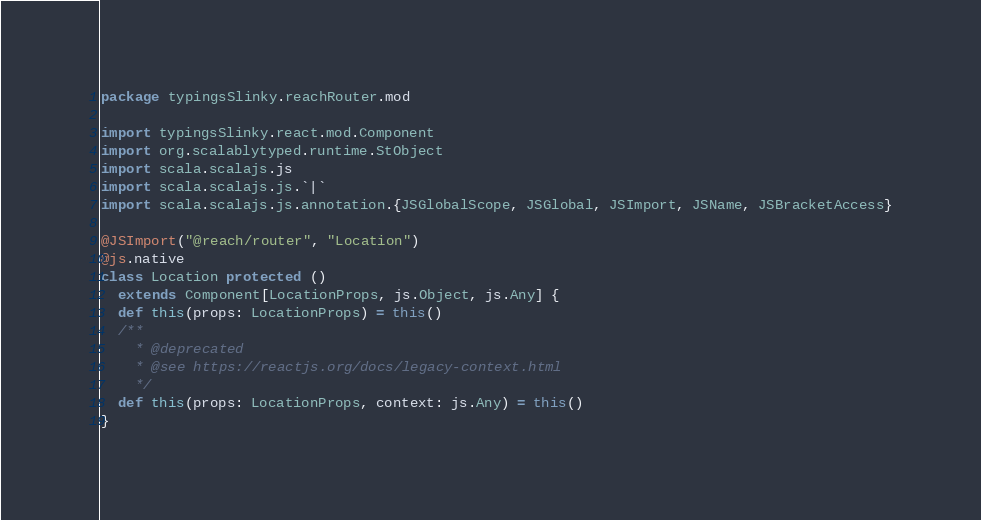Convert code to text. <code><loc_0><loc_0><loc_500><loc_500><_Scala_>package typingsSlinky.reachRouter.mod

import typingsSlinky.react.mod.Component
import org.scalablytyped.runtime.StObject
import scala.scalajs.js
import scala.scalajs.js.`|`
import scala.scalajs.js.annotation.{JSGlobalScope, JSGlobal, JSImport, JSName, JSBracketAccess}

@JSImport("@reach/router", "Location")
@js.native
class Location protected ()
  extends Component[LocationProps, js.Object, js.Any] {
  def this(props: LocationProps) = this()
  /**
    * @deprecated
    * @see https://reactjs.org/docs/legacy-context.html
    */
  def this(props: LocationProps, context: js.Any) = this()
}
</code> 